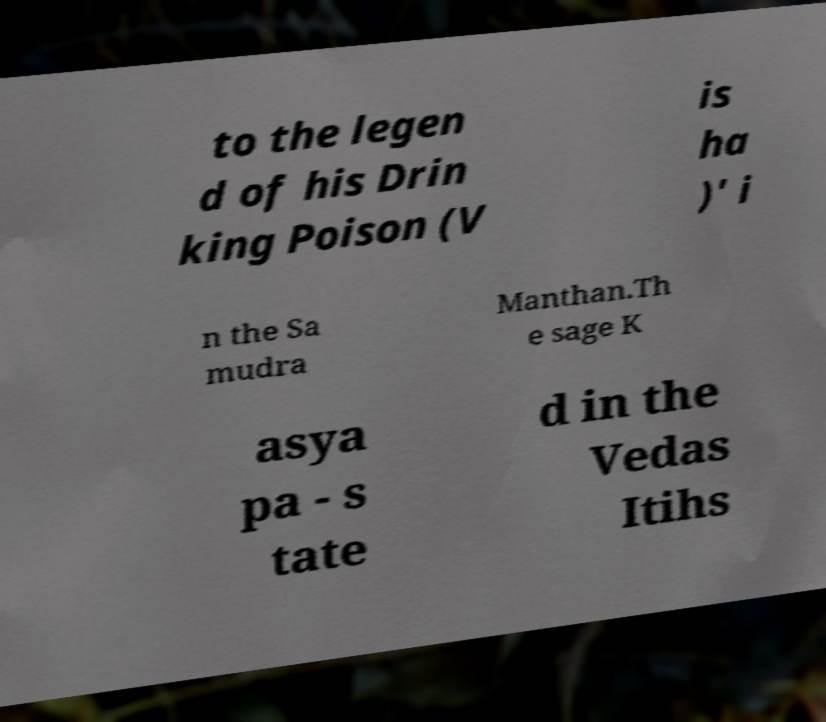What messages or text are displayed in this image? I need them in a readable, typed format. to the legen d of his Drin king Poison (V is ha )' i n the Sa mudra Manthan.Th e sage K asya pa - s tate d in the Vedas Itihs 